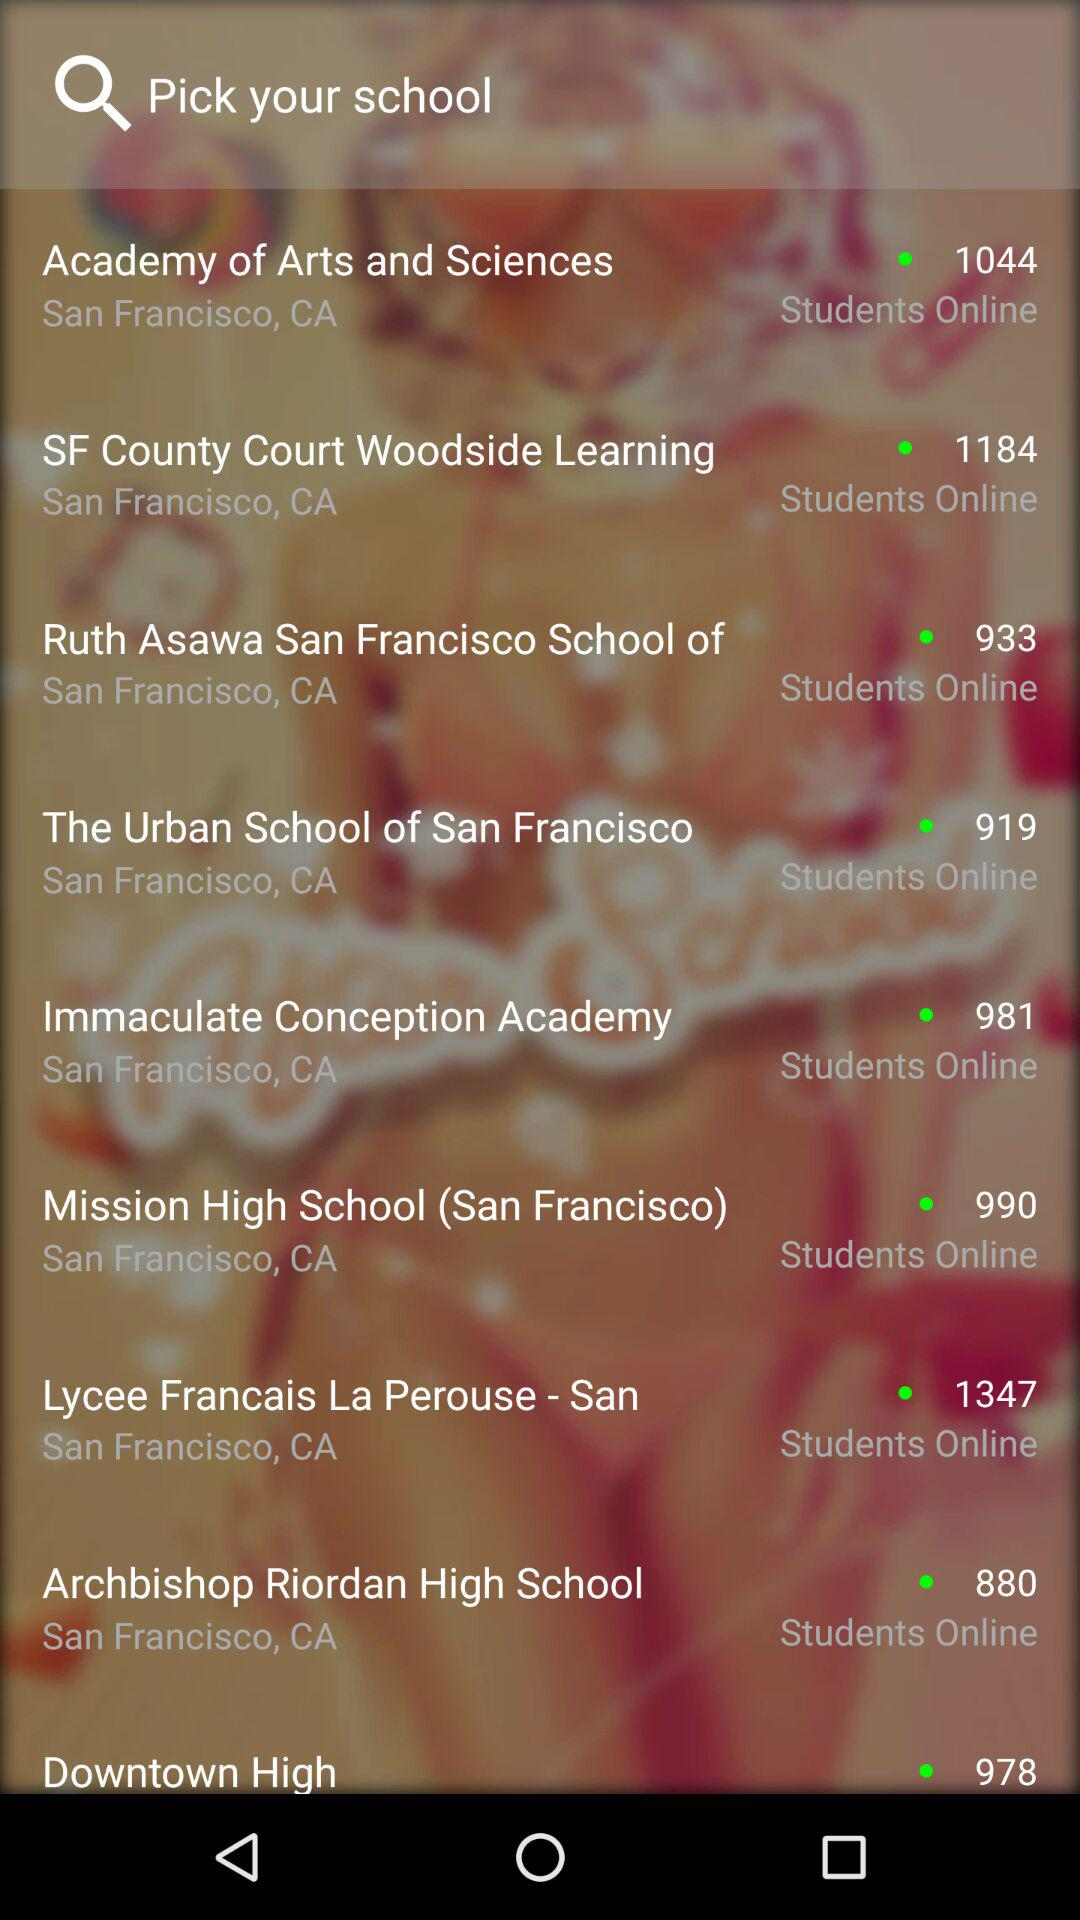What are the available schools? The available schools are "Academy of Arts and Sciences", "SF County Court Woodside Learning", "Ruth Asawa San Francisco School of", "The Urban School of San Francisco", "Immaculate Conception Academy", "Mission High School (San Francisco)", "Lycee Francais La Perouse - San", "Archbishop Riordan High School" and "Downtown High". 